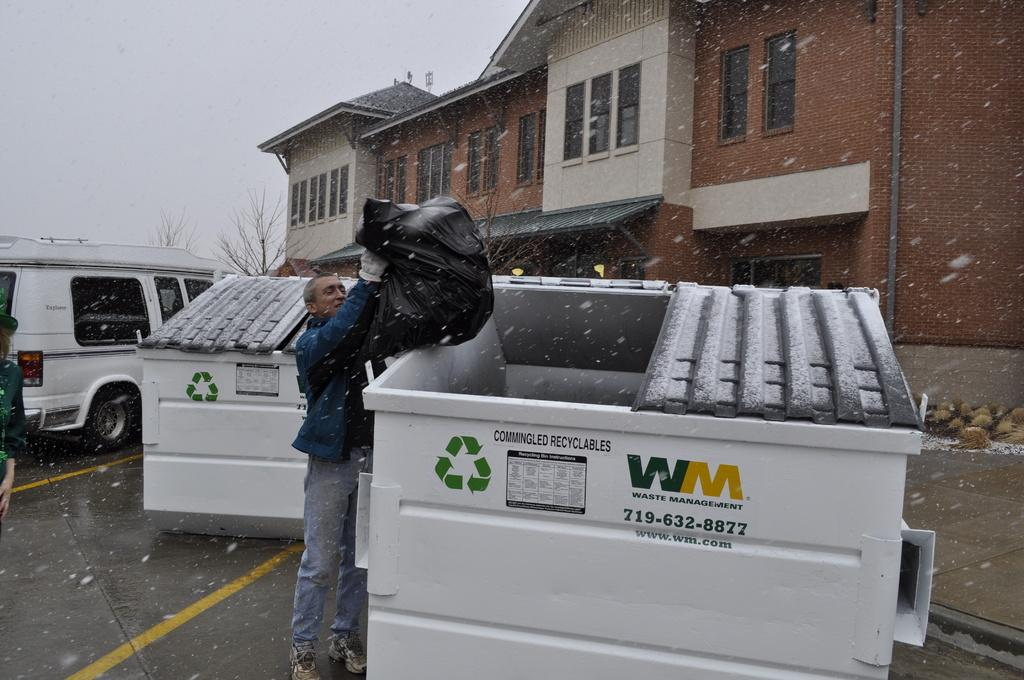What is the man in the image holding? The man is holding a plastic cover. What can be seen in the image besides the man? There are bins, a vehicle on the road, houses, windows, trees, and the sky visible in the background of the image. What type of structure is visible in the background of the image? There are houses in the background of the image. What natural elements can be seen in the background of the image? Trees and the sky are visible in the background of the image. What is the weight of the flower in the image? There is no flower present in the image, so it is not possible to determine its weight. 